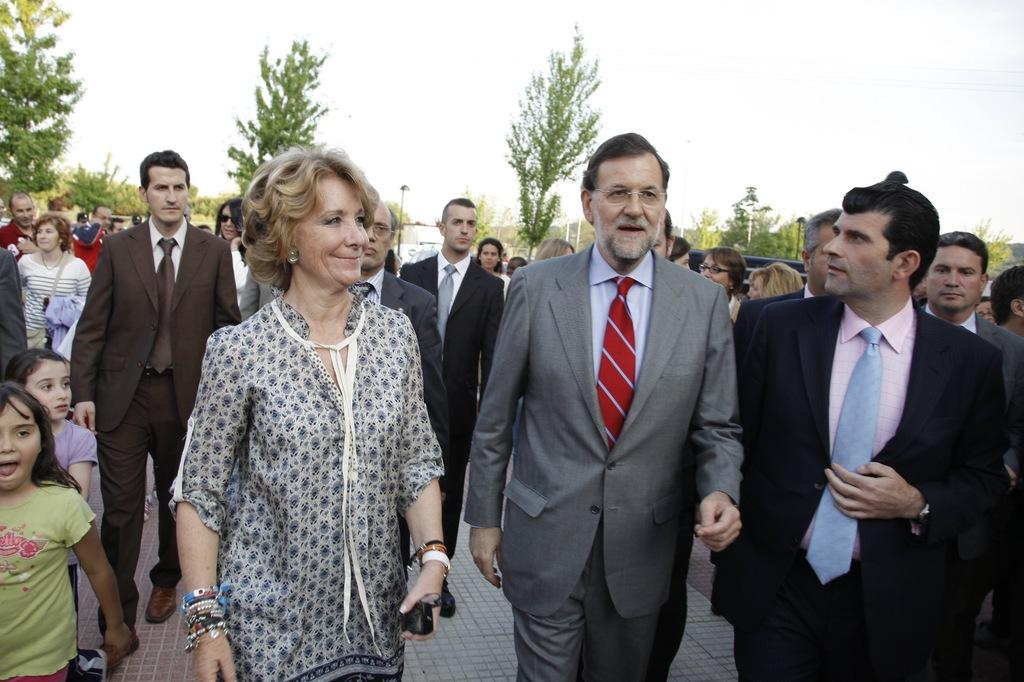What are the people in the image doing? There are people walking in the image. Can you describe the woman in the image? The woman is holding glasses and smiling. What can be seen in the background of the image? There are people, trees, and the sky visible in the background of the image. What type of suit is the woman wearing in the image? There is no suit visible in the image; the woman is holding glasses and smiling. 